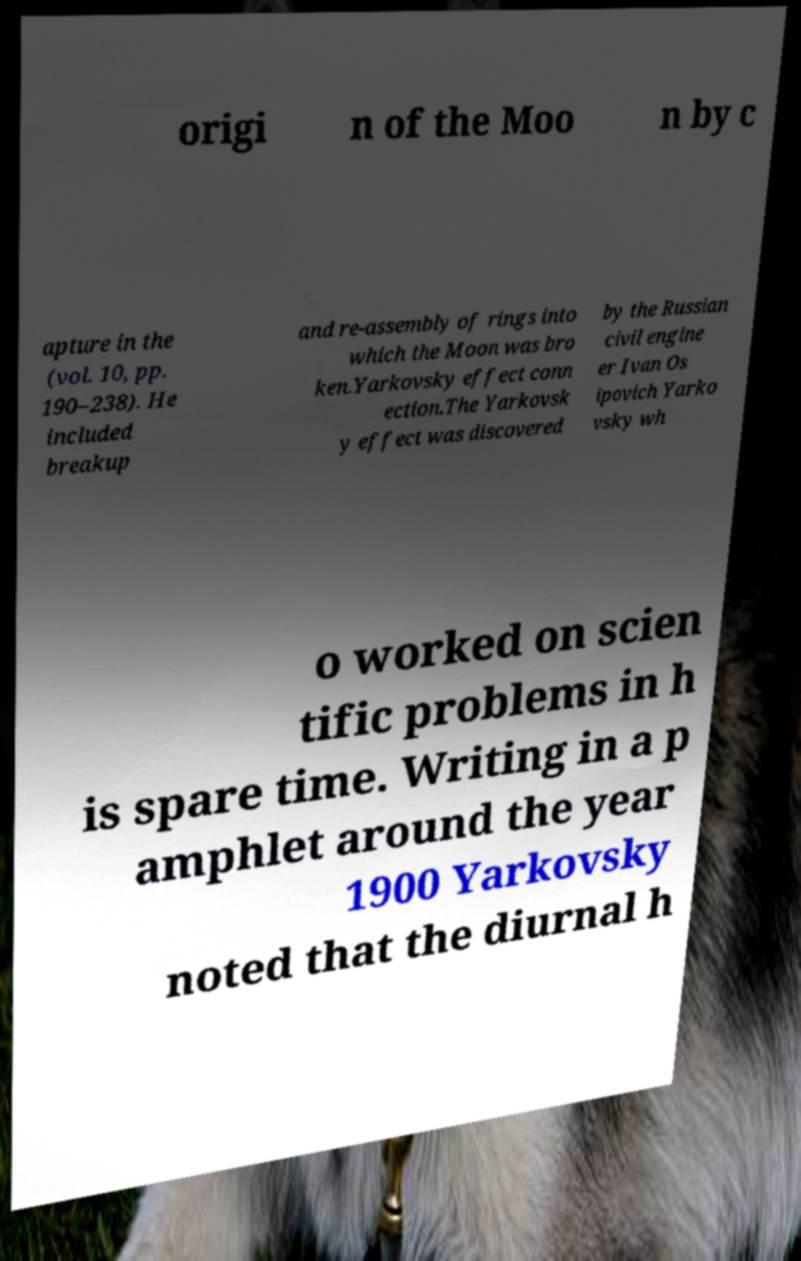Please identify and transcribe the text found in this image. origi n of the Moo n by c apture in the (vol. 10, pp. 190–238). He included breakup and re-assembly of rings into which the Moon was bro ken.Yarkovsky effect conn ection.The Yarkovsk y effect was discovered by the Russian civil engine er Ivan Os ipovich Yarko vsky wh o worked on scien tific problems in h is spare time. Writing in a p amphlet around the year 1900 Yarkovsky noted that the diurnal h 